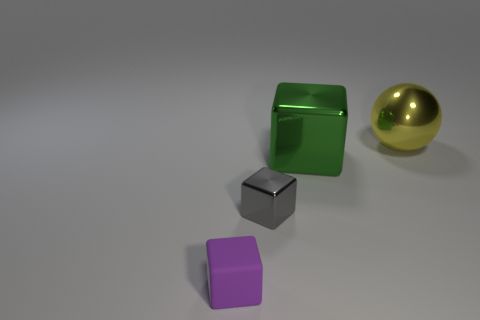Is the green thing the same shape as the purple object?
Offer a terse response. Yes. There is a large object that is in front of the large thing that is behind the large green object; what is its material?
Provide a succinct answer. Metal. Are there an equal number of green cubes that are left of the small purple thing and big red rubber spheres?
Ensure brevity in your answer.  Yes. There is a shiny thing that is both on the left side of the yellow metal object and behind the gray shiny block; what size is it?
Provide a succinct answer. Large. What color is the small cube to the left of the small cube behind the matte block?
Give a very brief answer. Purple. How many yellow objects are shiny objects or big metal objects?
Ensure brevity in your answer.  1. The thing that is to the left of the yellow object and behind the small gray object is what color?
Your answer should be very brief. Green. How many tiny objects are either rubber objects or gray things?
Give a very brief answer. 2. What is the size of the other matte object that is the same shape as the gray thing?
Provide a short and direct response. Small. What shape is the large green thing?
Your answer should be very brief. Cube. 